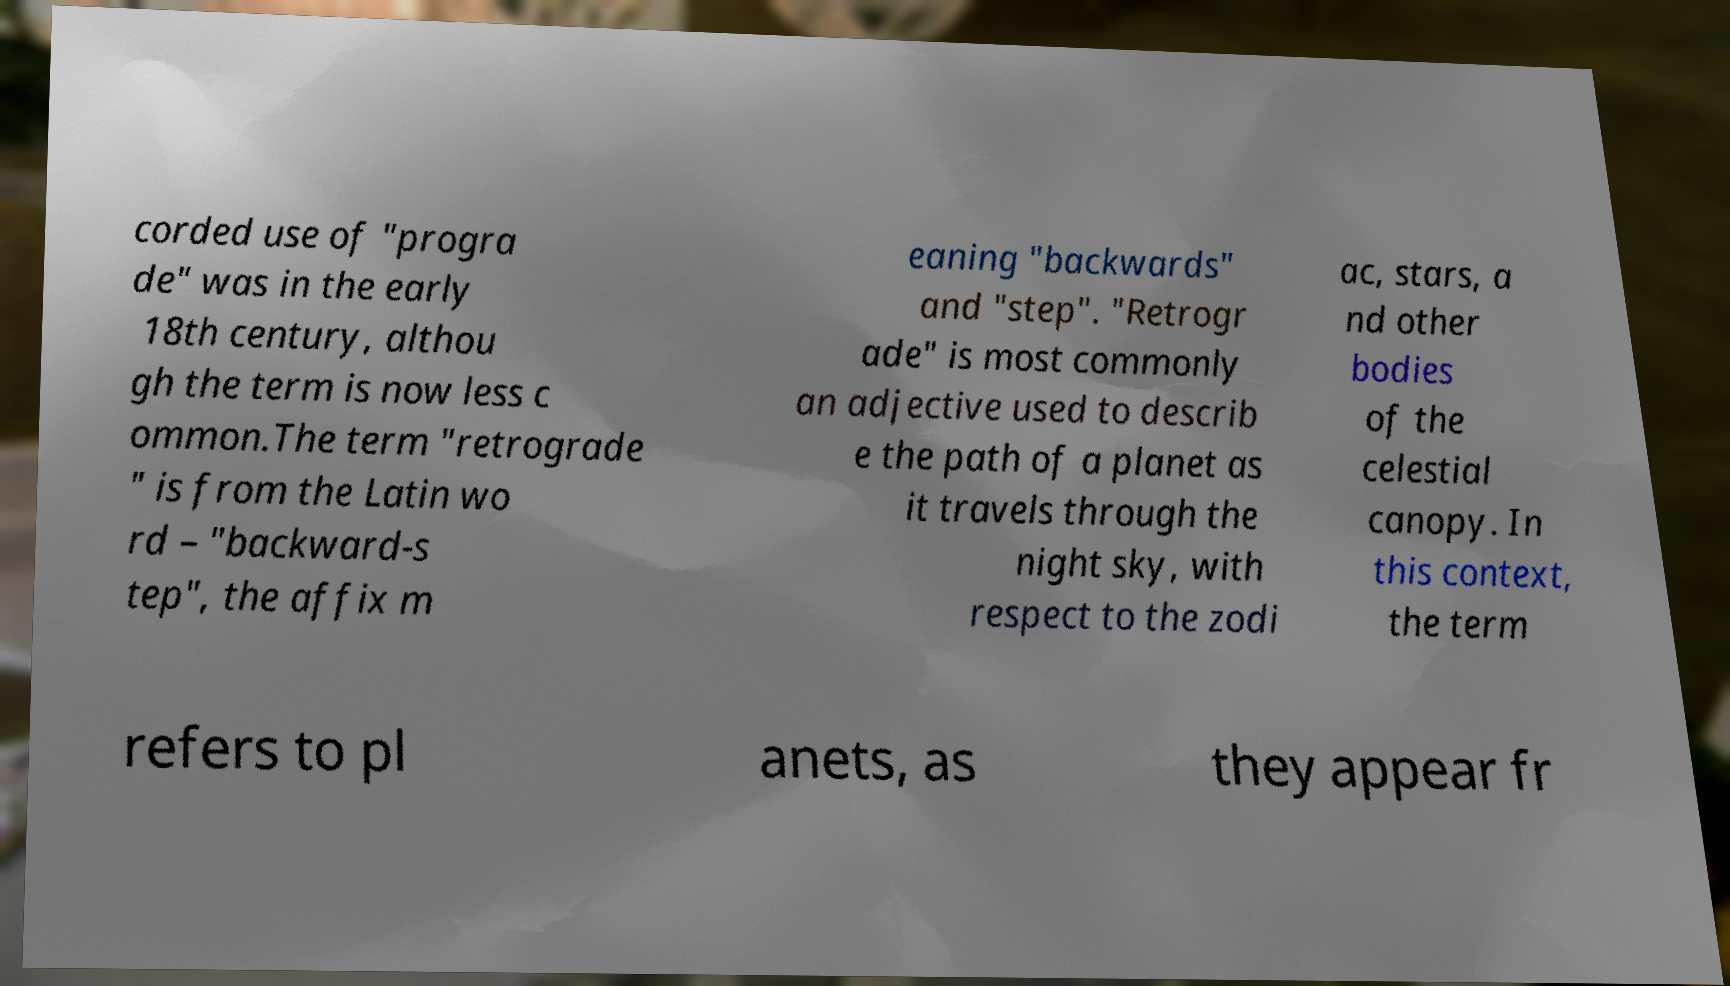I need the written content from this picture converted into text. Can you do that? corded use of "progra de" was in the early 18th century, althou gh the term is now less c ommon.The term "retrograde " is from the Latin wo rd – "backward-s tep", the affix m eaning "backwards" and "step". "Retrogr ade" is most commonly an adjective used to describ e the path of a planet as it travels through the night sky, with respect to the zodi ac, stars, a nd other bodies of the celestial canopy. In this context, the term refers to pl anets, as they appear fr 